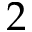<formula> <loc_0><loc_0><loc_500><loc_500>2</formula> 